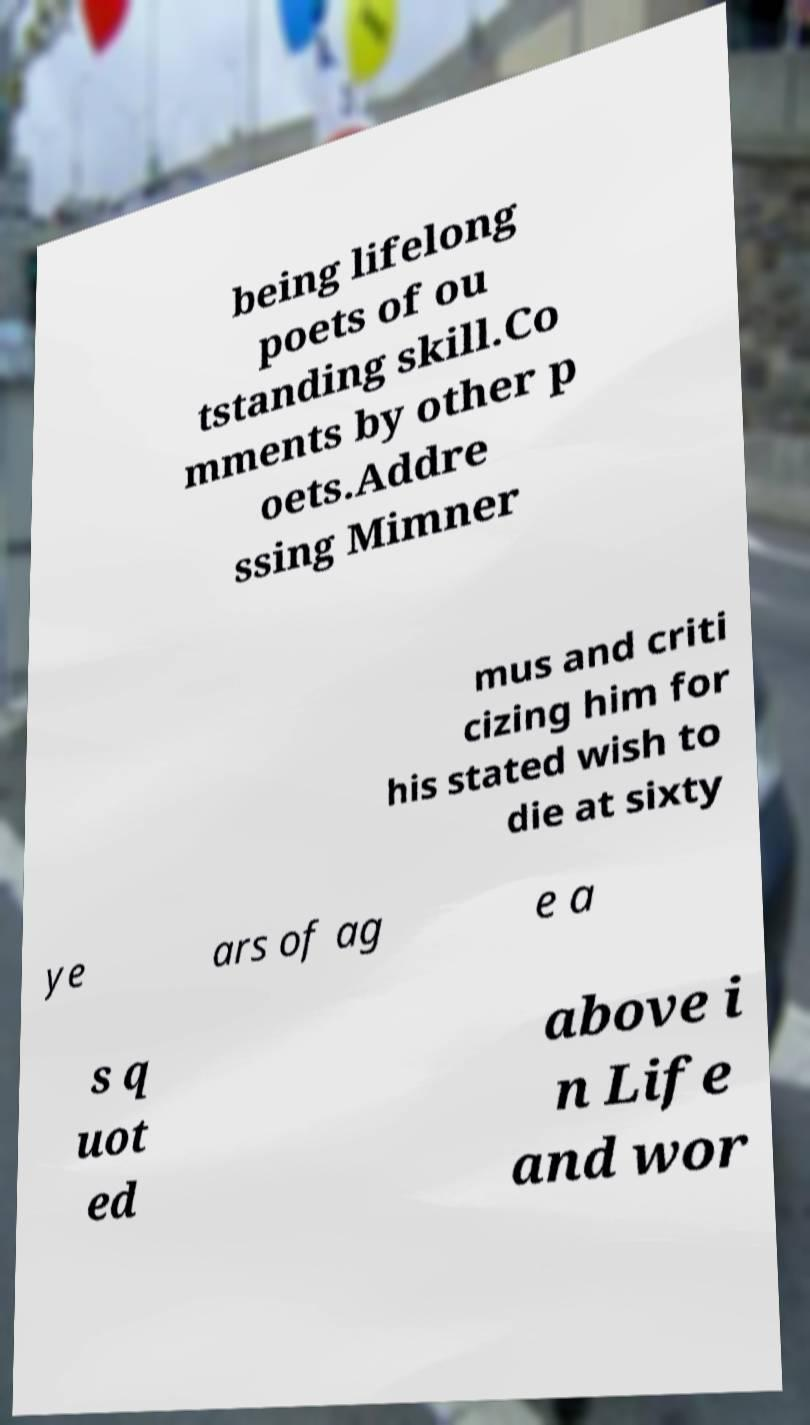Please read and relay the text visible in this image. What does it say? being lifelong poets of ou tstanding skill.Co mments by other p oets.Addre ssing Mimner mus and criti cizing him for his stated wish to die at sixty ye ars of ag e a s q uot ed above i n Life and wor 